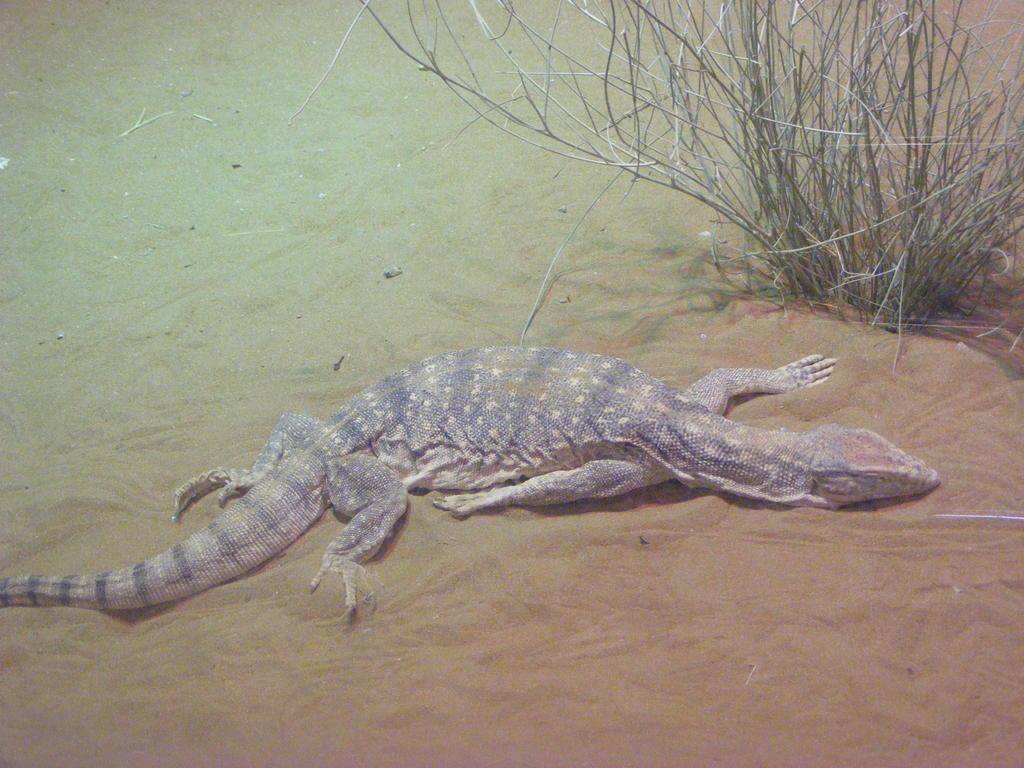What type of animal is in the image? There is a reptile in the image. What is the reptile's location in the image? The reptile is on the sand. What type of vegetation is visible in the background of the image? There is green grass in the background of the image. What color is the sweater that the reptile is wearing in the image? There is no sweater present in the image, as reptiles do not wear clothing. Is there a fight happening between the reptile and another animal in the image? There is no fight depicted in the image; the reptile is simply on the sand. 